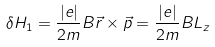Convert formula to latex. <formula><loc_0><loc_0><loc_500><loc_500>\delta H _ { 1 } = \frac { | e | } { 2 m } B \vec { r } \times \vec { p } = \frac { | e | } { 2 m } B L _ { z }</formula> 